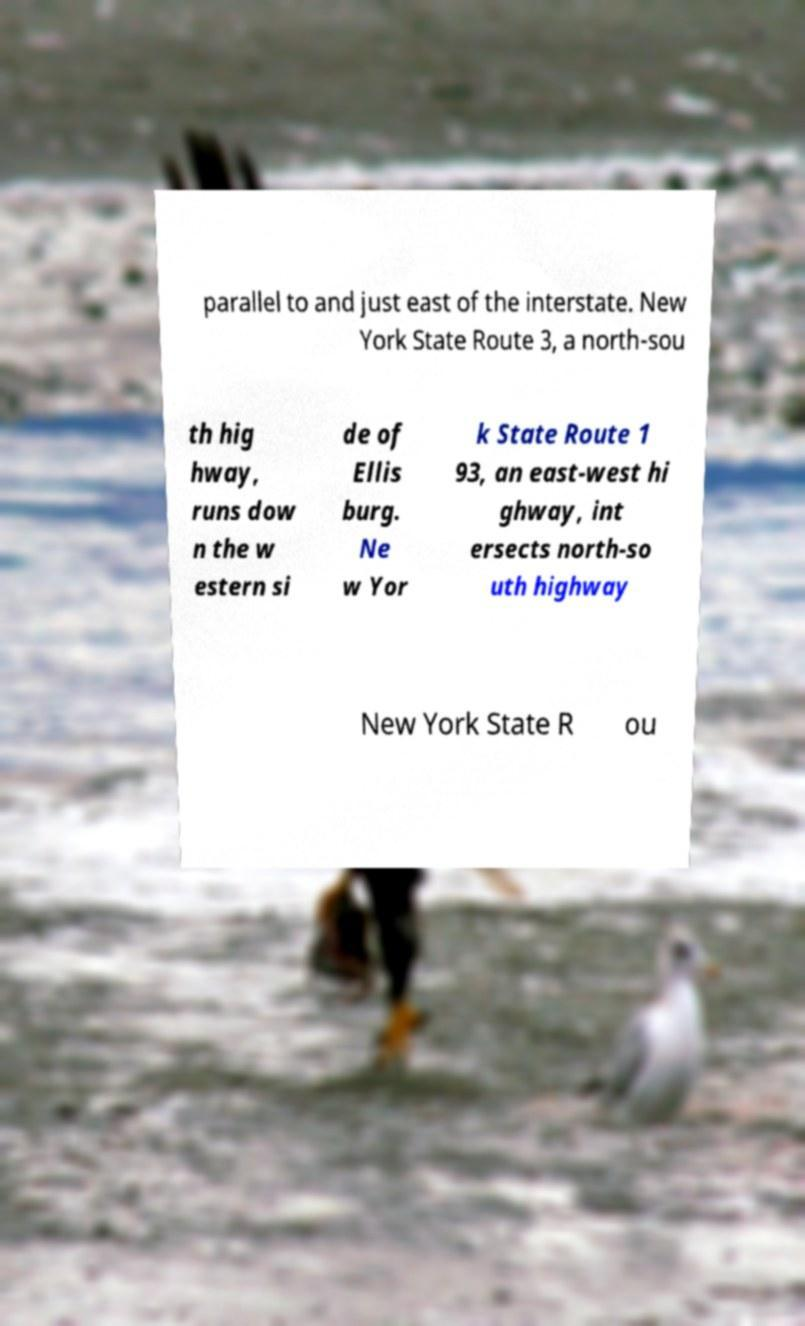I need the written content from this picture converted into text. Can you do that? parallel to and just east of the interstate. New York State Route 3, a north-sou th hig hway, runs dow n the w estern si de of Ellis burg. Ne w Yor k State Route 1 93, an east-west hi ghway, int ersects north-so uth highway New York State R ou 